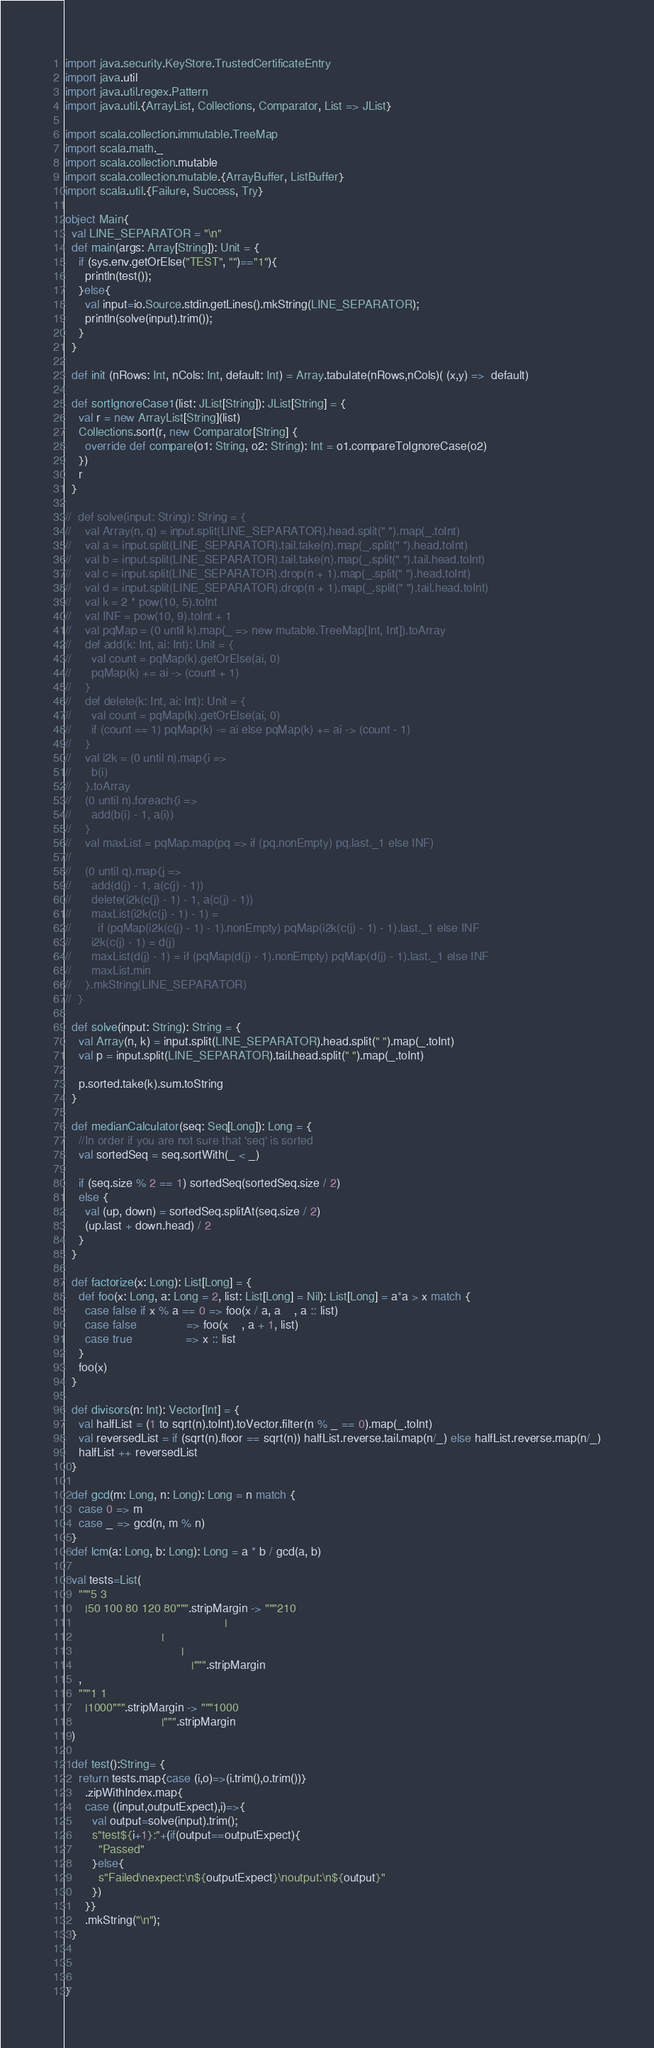<code> <loc_0><loc_0><loc_500><loc_500><_Scala_>import java.security.KeyStore.TrustedCertificateEntry
import java.util
import java.util.regex.Pattern
import java.util.{ArrayList, Collections, Comparator, List => JList}

import scala.collection.immutable.TreeMap
import scala.math._
import scala.collection.mutable
import scala.collection.mutable.{ArrayBuffer, ListBuffer}
import scala.util.{Failure, Success, Try}

object Main{
  val LINE_SEPARATOR = "\n"
  def main(args: Array[String]): Unit = {
    if (sys.env.getOrElse("TEST", "")=="1"){
      println(test());
    }else{
      val input=io.Source.stdin.getLines().mkString(LINE_SEPARATOR);
      println(solve(input).trim());
    }
  }

  def init (nRows: Int, nCols: Int, default: Int) = Array.tabulate(nRows,nCols)( (x,y) =>  default)

  def sortIgnoreCase1(list: JList[String]): JList[String] = {
    val r = new ArrayList[String](list)
    Collections.sort(r, new Comparator[String] {
      override def compare(o1: String, o2: String): Int = o1.compareToIgnoreCase(o2)
    })
    r
  }

//  def solve(input: String): String = {
//    val Array(n, q) = input.split(LINE_SEPARATOR).head.split(" ").map(_.toInt)
//    val a = input.split(LINE_SEPARATOR).tail.take(n).map(_.split(" ").head.toInt)
//    val b = input.split(LINE_SEPARATOR).tail.take(n).map(_.split(" ").tail.head.toInt)
//    val c = input.split(LINE_SEPARATOR).drop(n + 1).map(_.split(" ").head.toInt)
//    val d = input.split(LINE_SEPARATOR).drop(n + 1).map(_.split(" ").tail.head.toInt)
//    val k = 2 * pow(10, 5).toInt
//    val INF = pow(10, 9).toInt + 1
//    val pqMap = (0 until k).map(_ => new mutable.TreeMap[Int, Int]).toArray
//    def add(k: Int, ai: Int): Unit = {
//      val count = pqMap(k).getOrElse(ai, 0)
//      pqMap(k) += ai -> (count + 1)
//    }
//    def delete(k: Int, ai: Int): Unit = {
//      val count = pqMap(k).getOrElse(ai, 0)
//      if (count == 1) pqMap(k) -= ai else pqMap(k) += ai -> (count - 1)
//    }
//    val i2k = (0 until n).map{i =>
//      b(i)
//    }.toArray
//    (0 until n).foreach{i =>
//      add(b(i) - 1, a(i))
//    }
//    val maxList = pqMap.map(pq => if (pq.nonEmpty) pq.last._1 else INF)
//
//    (0 until q).map{j =>
//      add(d(j) - 1, a(c(j) - 1))
//      delete(i2k(c(j) - 1) - 1, a(c(j) - 1))
//      maxList(i2k(c(j) - 1) - 1) =
//        if (pqMap(i2k(c(j) - 1) - 1).nonEmpty) pqMap(i2k(c(j) - 1) - 1).last._1 else INF
//      i2k(c(j) - 1) = d(j)
//      maxList(d(j) - 1) = if (pqMap(d(j) - 1).nonEmpty) pqMap(d(j) - 1).last._1 else INF
//      maxList.min
//    }.mkString(LINE_SEPARATOR)
//  }

  def solve(input: String): String = {
    val Array(n, k) = input.split(LINE_SEPARATOR).head.split(" ").map(_.toInt)
    val p = input.split(LINE_SEPARATOR).tail.head.split(" ").map(_.toInt)

    p.sorted.take(k).sum.toString
  }

  def medianCalculator(seq: Seq[Long]): Long = {
    //In order if you are not sure that 'seq' is sorted
    val sortedSeq = seq.sortWith(_ < _)

    if (seq.size % 2 == 1) sortedSeq(sortedSeq.size / 2)
    else {
      val (up, down) = sortedSeq.splitAt(seq.size / 2)
      (up.last + down.head) / 2
    }
  }

  def factorize(x: Long): List[Long] = {
    def foo(x: Long, a: Long = 2, list: List[Long] = Nil): List[Long] = a*a > x match {
      case false if x % a == 0 => foo(x / a, a    , a :: list)
      case false               => foo(x    , a + 1, list)
      case true                => x :: list
    }
    foo(x)
  }

  def divisors(n: Int): Vector[Int] = {
    val halfList = (1 to sqrt(n).toInt).toVector.filter(n % _ == 0).map(_.toInt)
    val reversedList = if (sqrt(n).floor == sqrt(n)) halfList.reverse.tail.map(n/_) else halfList.reverse.map(n/_)
    halfList ++ reversedList
  }

  def gcd(m: Long, n: Long): Long = n match {
    case 0 => m
    case _ => gcd(n, m % n)
  }
  def lcm(a: Long, b: Long): Long = a * b / gcd(a, b)

  val tests=List(
    """5 3
      |50 100 80 120 80""".stripMargin -> """210
                                                |
                             |
                                   |
                                      |""".stripMargin
    ,
    """1 1
      |1000""".stripMargin -> """1000
                             |""".stripMargin
  )

  def test():String= {
    return tests.map{case (i,o)=>(i.trim(),o.trim())}
      .zipWithIndex.map{
      case ((input,outputExpect),i)=>{
        val output=solve(input).trim();
        s"test${i+1}:"+(if(output==outputExpect){
          "Passed"
        }else{
          s"Failed\nexpect:\n${outputExpect}\noutput:\n${output}"
        })
      }}
      .mkString("\n");
  }



}
</code> 